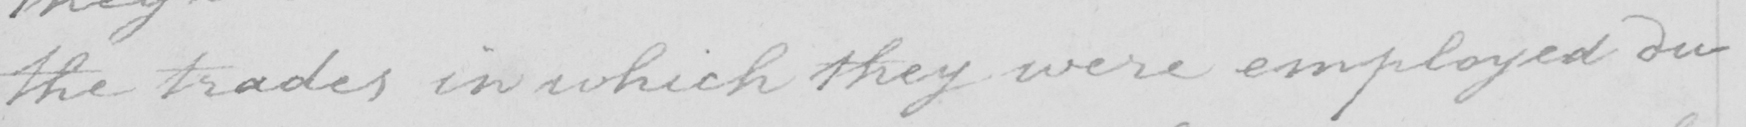Can you tell me what this handwritten text says? the trades in which they were employed du- 